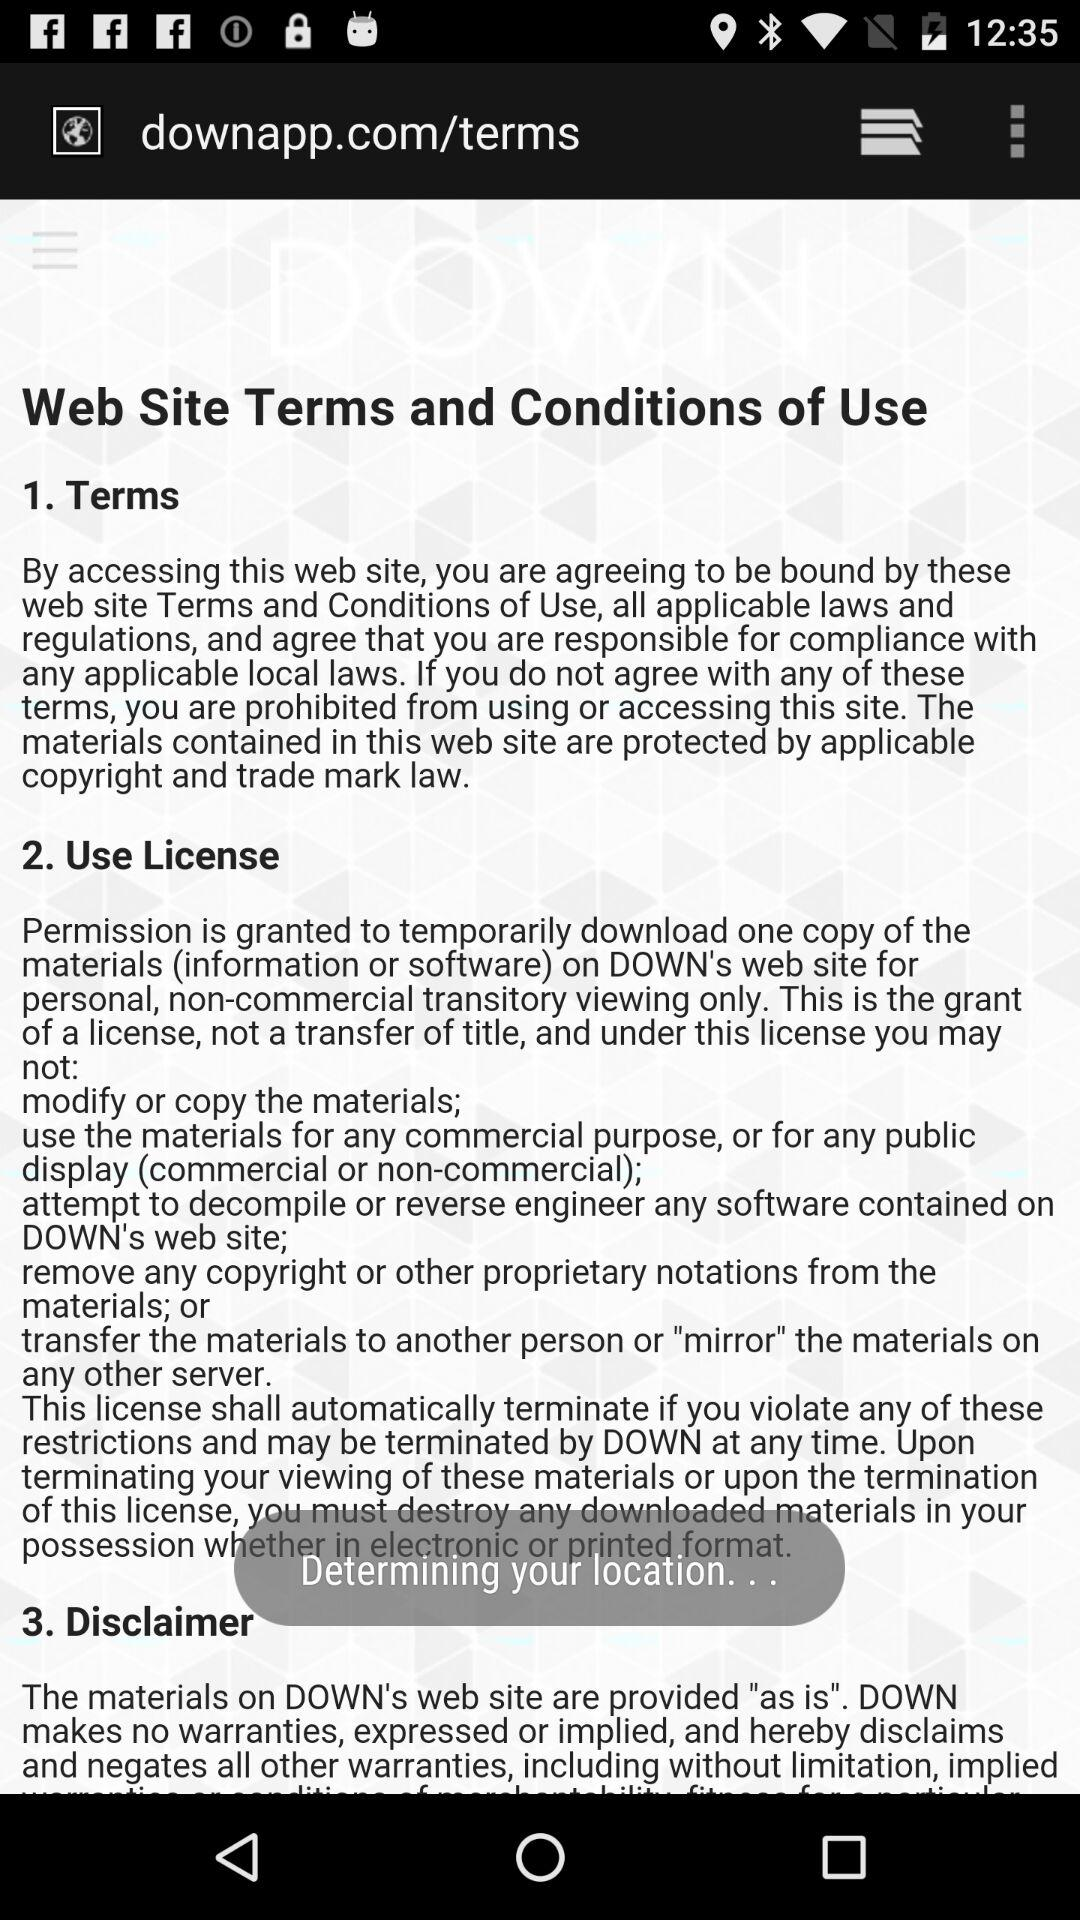How many sections are there in this terms and conditions document?
Answer the question using a single word or phrase. 3 